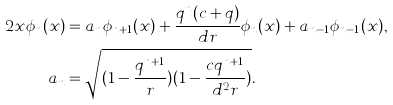Convert formula to latex. <formula><loc_0><loc_0><loc_500><loc_500>2 x \phi _ { n } ( x ) & = a _ { n } \phi _ { n + 1 } ( x ) + \frac { q ^ { n } ( c + q ) } { d r } \phi _ { n } ( x ) + a _ { n - 1 } \phi _ { n - 1 } ( x ) , \\ a _ { n } & = \sqrt { ( 1 - \frac { q ^ { n + 1 } } { r } ) ( 1 - \frac { c q ^ { n + 1 } } { d ^ { 2 } r } ) } .</formula> 